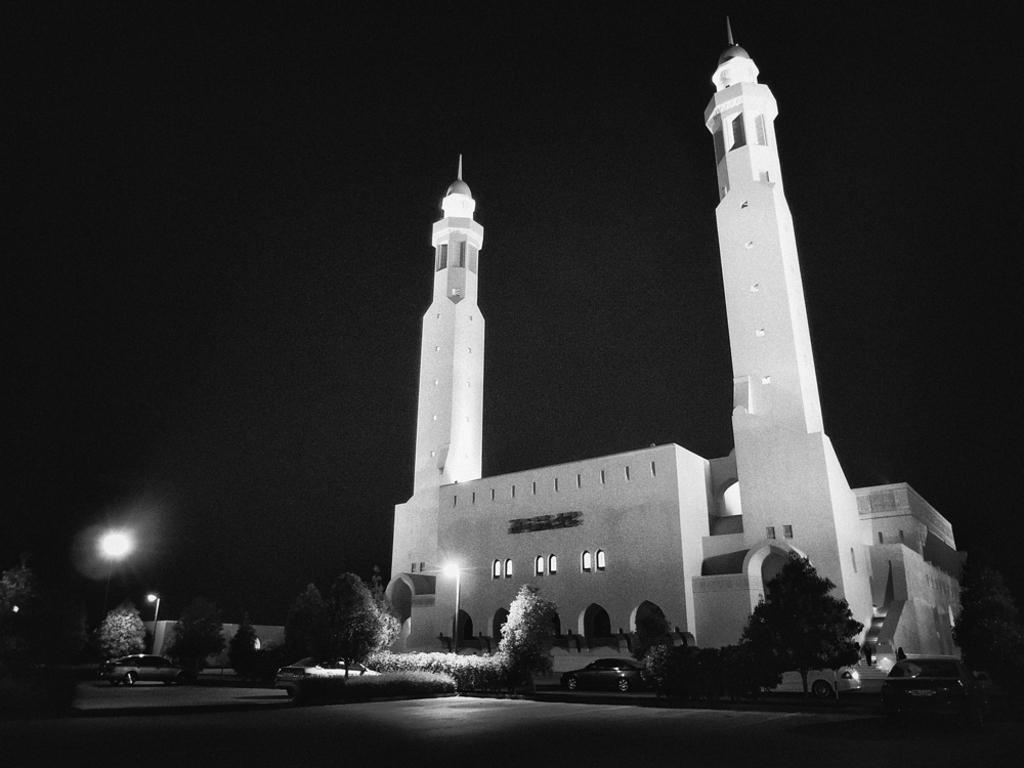Could you give a brief overview of what you see in this image? In the center of the image there is a mosque. There are trees. There are street lights. 